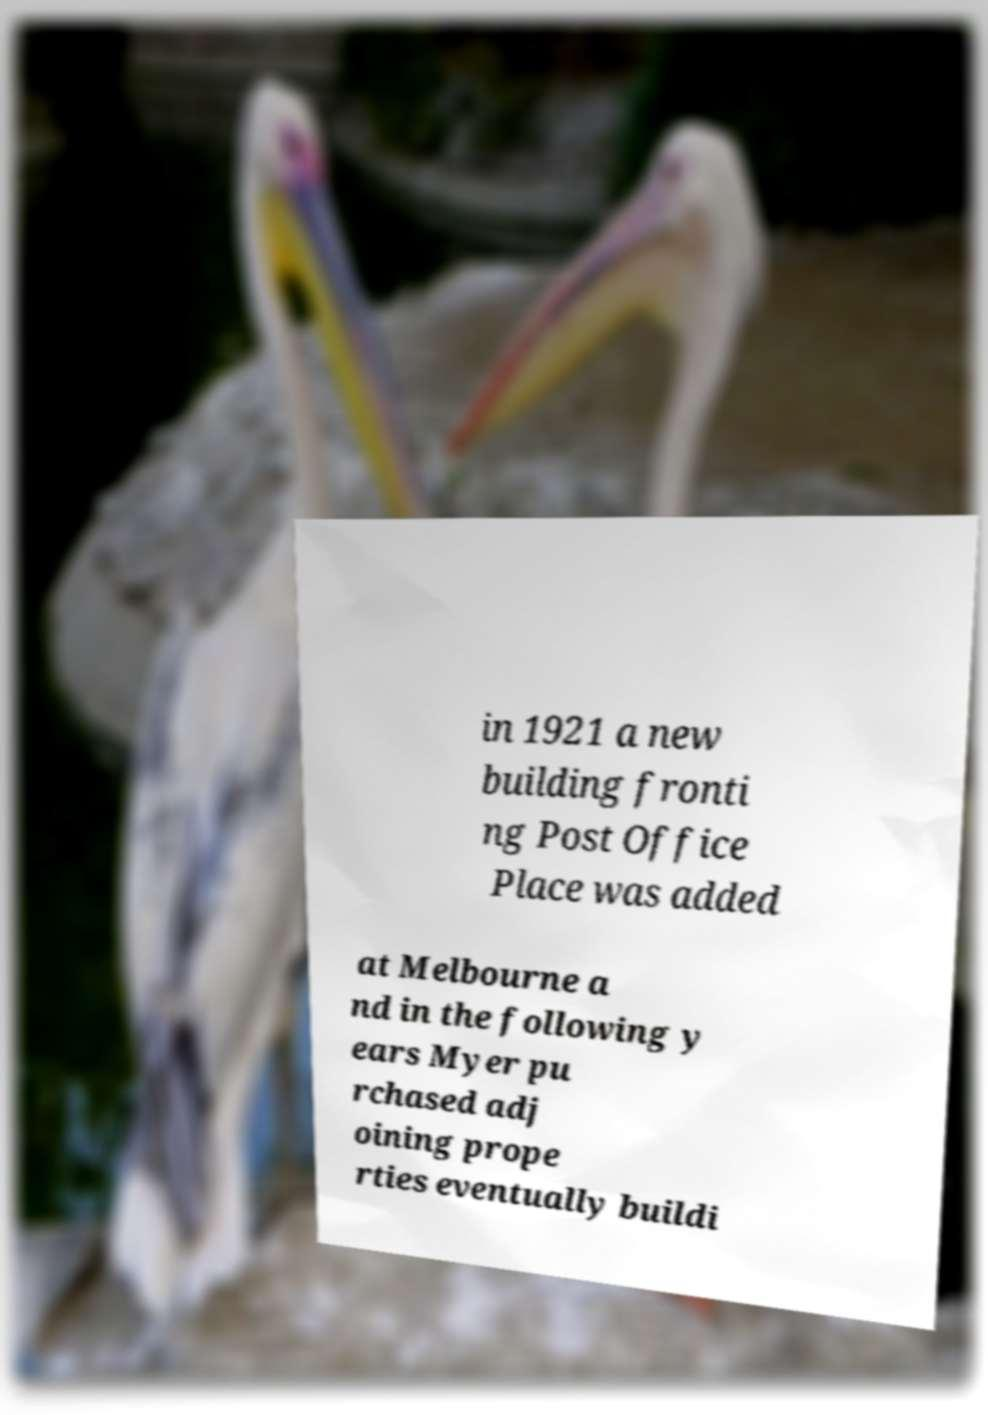Can you accurately transcribe the text from the provided image for me? in 1921 a new building fronti ng Post Office Place was added at Melbourne a nd in the following y ears Myer pu rchased adj oining prope rties eventually buildi 